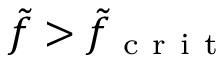<formula> <loc_0><loc_0><loc_500><loc_500>\tilde { f } > \tilde { f } _ { c r i t }</formula> 